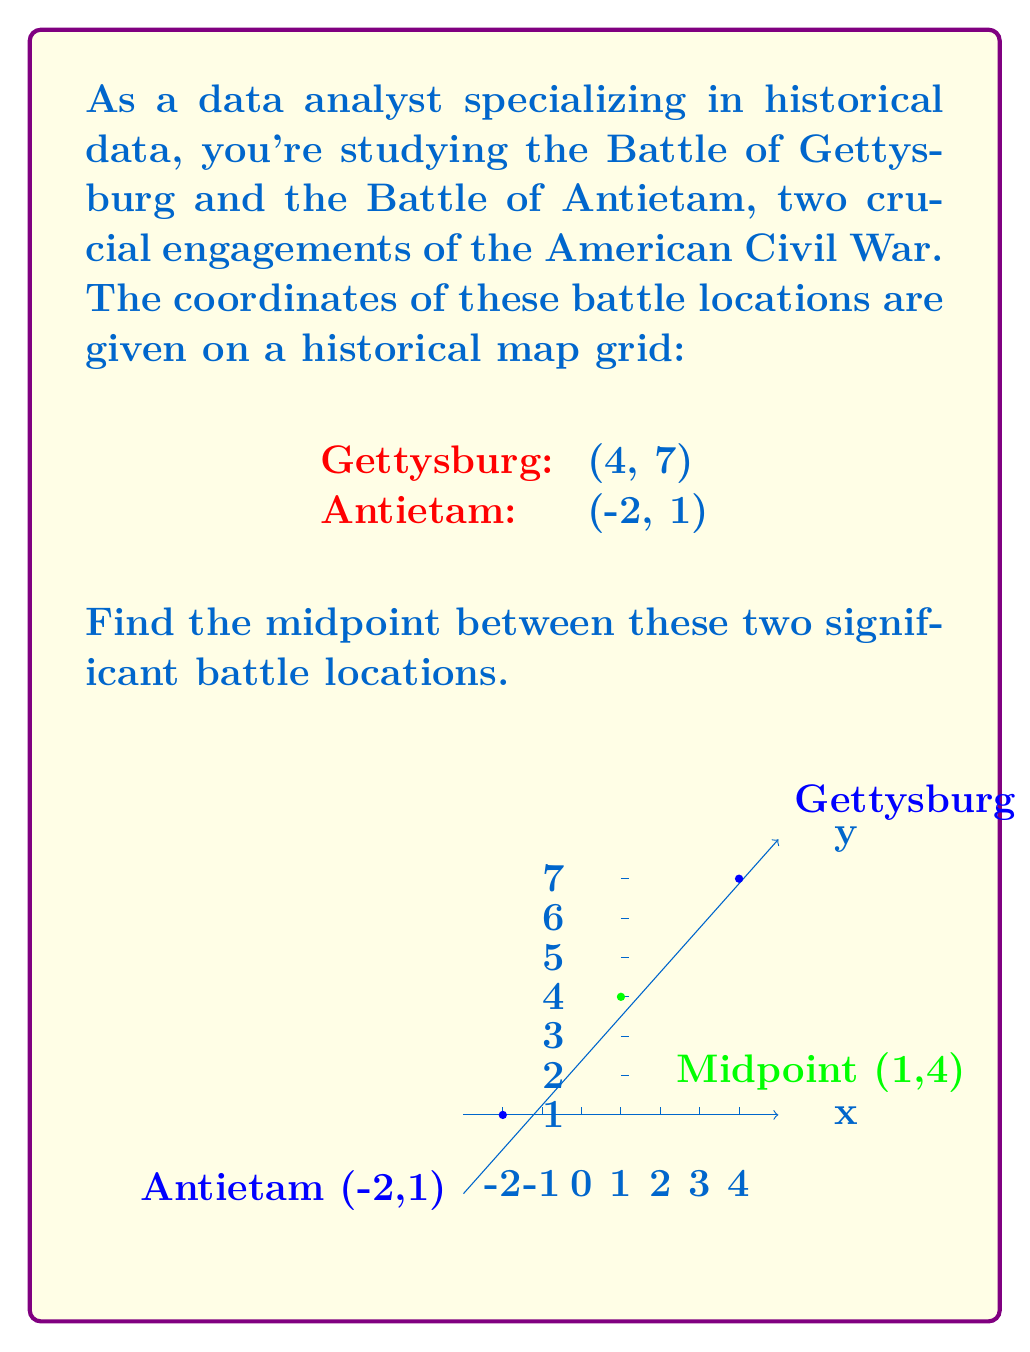Solve this math problem. To find the midpoint between two points, we use the midpoint formula:

$$ \text{Midpoint} = \left(\frac{x_1 + x_2}{2}, \frac{y_1 + y_2}{2}\right) $$

Where $(x_1, y_1)$ and $(x_2, y_2)$ are the coordinates of the two points.

Let's assign our points:
Gettysburg: $(x_1, y_1) = (4, 7)$
Antietam: $(x_2, y_2) = (-2, 1)$

Now, let's calculate the x-coordinate of the midpoint:

$$ x = \frac{x_1 + x_2}{2} = \frac{4 + (-2)}{2} = \frac{2}{2} = 1 $$

Next, let's calculate the y-coordinate of the midpoint:

$$ y = \frac{y_1 + y_2}{2} = \frac{7 + 1}{2} = \frac{8}{2} = 4 $$

Therefore, the midpoint coordinates are $(1, 4)$.
Answer: (1, 4) 